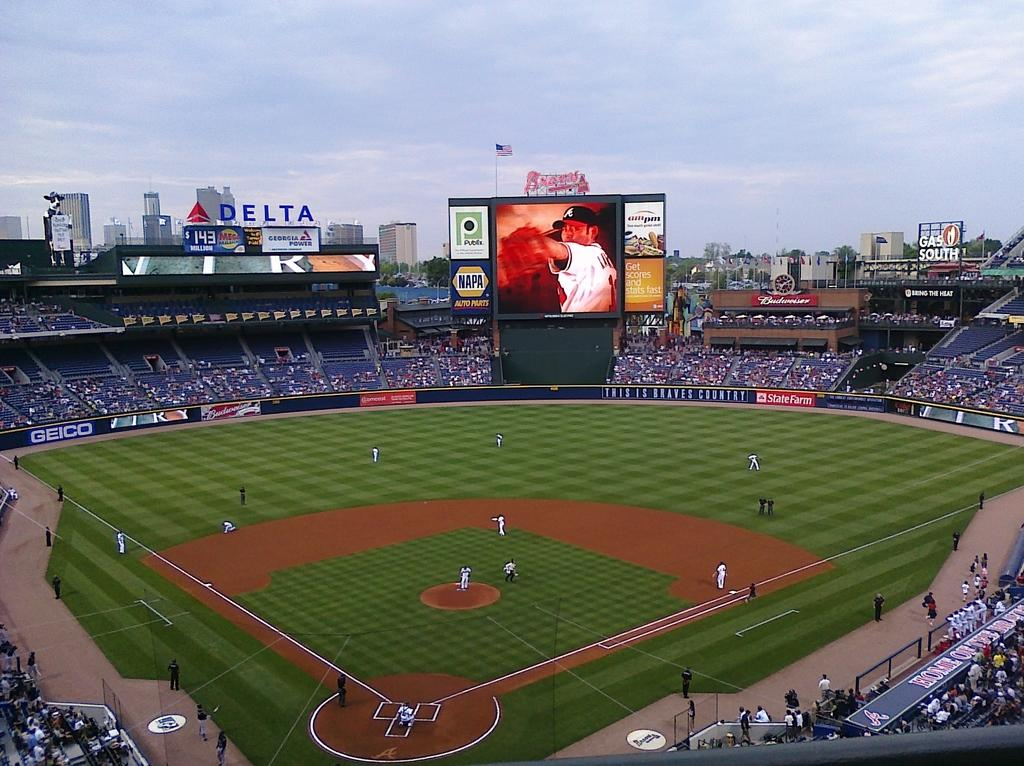<image>
Present a compact description of the photo's key features. A jumbtron screen with a Napa ad on it. 